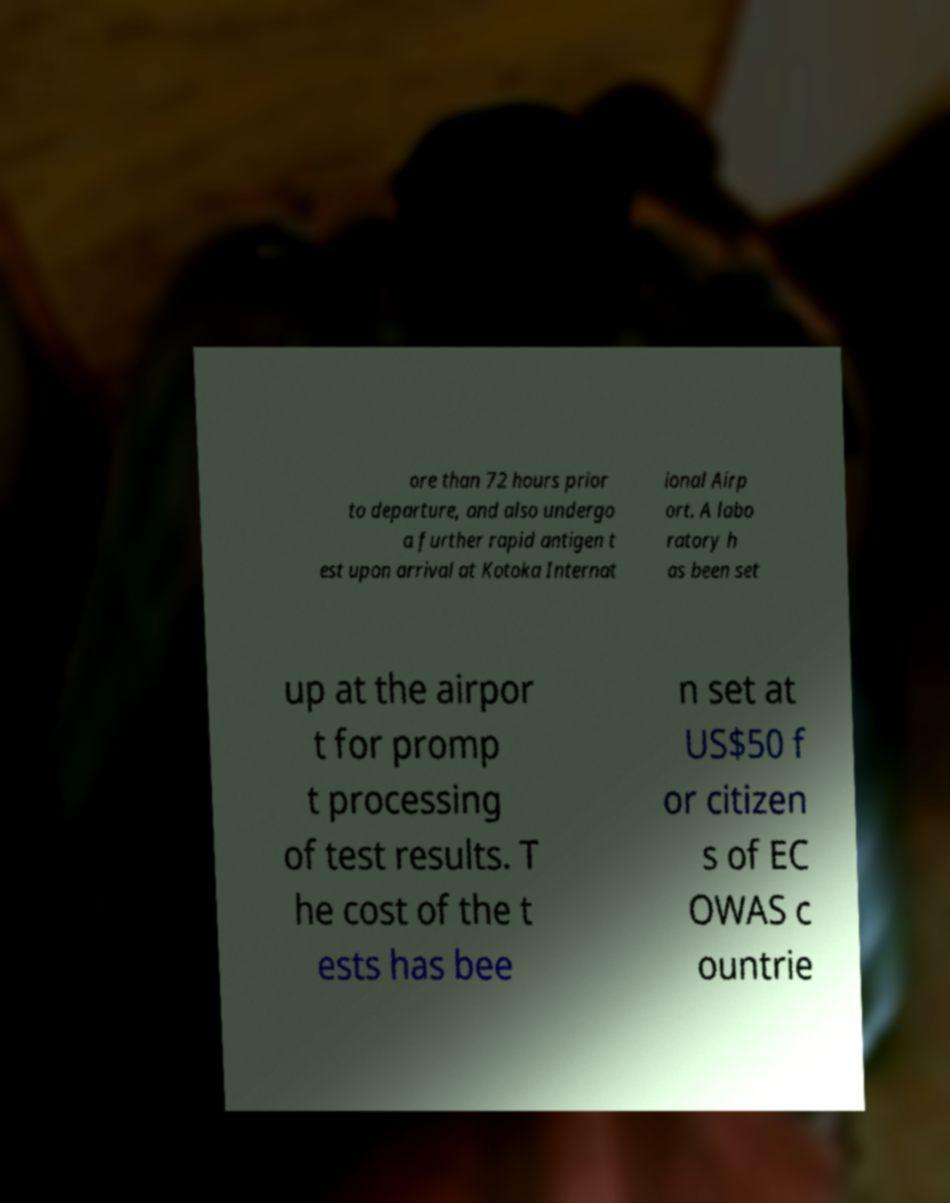What messages or text are displayed in this image? I need them in a readable, typed format. ore than 72 hours prior to departure, and also undergo a further rapid antigen t est upon arrival at Kotoka Internat ional Airp ort. A labo ratory h as been set up at the airpor t for promp t processing of test results. T he cost of the t ests has bee n set at US$50 f or citizen s of EC OWAS c ountrie 